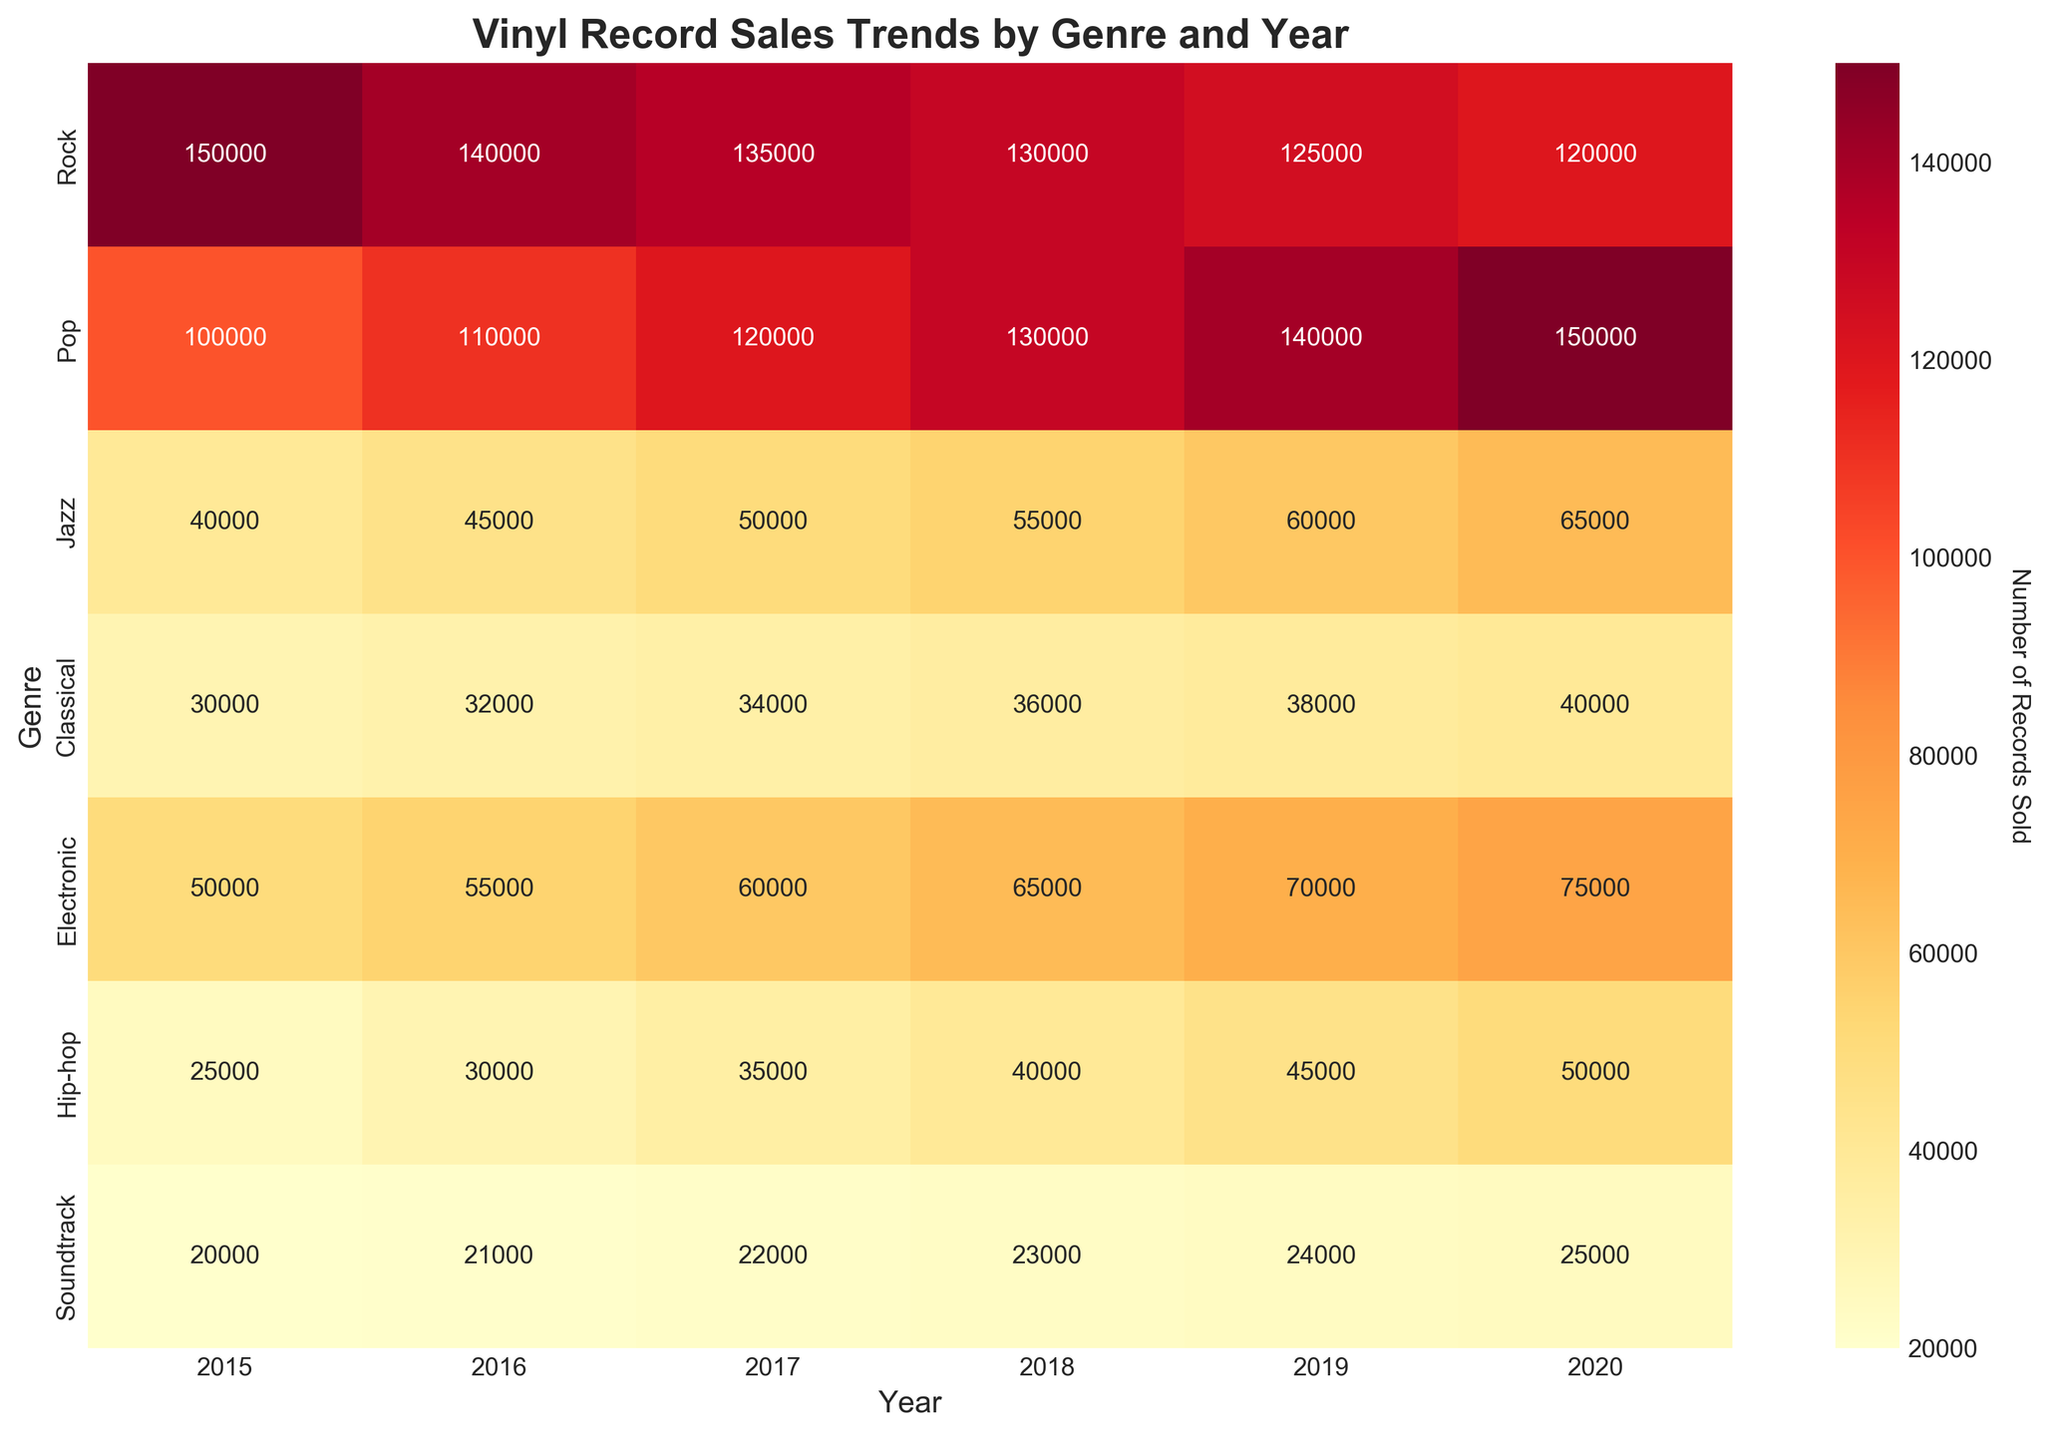What genre had the highest vinyl record sales in 2015? By looking at the heatmap, identify the box in the 2015 column with the highest value. The highest value in 2015 corresponds to the Rock genre with 150,000 records sold.
Answer: Rock Which genre shows a consistent increase in vinyl record sales from 2015 to 2020? Examine the trend for each genre across the years. Identify the genre where the sales figures increase every year. The Pop genre shows a consistent increase.
Answer: Pop How did the vinyl record sales for Jazz change from 2015 to 2020? Look at the data values for Jazz across all the years. Calculating the difference between the values of 2020 and 2015 shows an increase from 40,000 in 2015 to 65,000 in 2020.
Answer: Increased By how much did sales for Classical records change from 2017 to 2018? Check the sales figures for Classical in 2017 and 2018. The sales went from 34,000 in 2017 to 36,000 in 2018. Subtract 34,000 from 36,000 to find the increase of 2,000.
Answer: 2,000 Which genre had the lowest sales in 2020, and what was that number? Identify the genre with the smallest value in the 2020 column on the heatmap. The Soundtrack genre had the lowest sales with 25,000 records sold.
Answer: Soundtrack, 25,000 What is the average vinyl record sales for Hip-hop from 2015 to 2020? Add the sales figures for Hip-hop from 2015 to 2020 and divide by the number of years, which is 6. (25,000 + 30,000 + 35,000 + 40,000 + 45,000 + 50,000) / 6 = 37,500.
Answer: 37,500 Which year saw the highest overall sales for Pop records? Look at the sales figures for Pop across all years. The highest value is in the 2020 column with 150,000 records sold.
Answer: 2020 Do any genres show a decreasing trend in vinyl record sales from 2015 to 2020? Check each genre's trend over the years to see if the sales figures decrease consistently over time. Rock shows a consistent decrease from 150,000 in 2015 to 120,000 in 2020.
Answer: Rock What is the total number of Classical records sold from 2015 to 2020? Calculate the sum of the annual sales for Classical from 2015 to 2020. 30,000 + 32,000 + 34,000 + 36,000 + 38,000 + 40,000 = 210,000.
Answer: 210,000 Which genre had the second highest increase in vinyl record sales from 2015 to 2020, after Pop? Calculate the increase for each genre from 2015 to 2020. Pop had the highest increase, followed by Electronic with an increase from 50,000 to 75,000, which is 25,000.
Answer: Electronic 